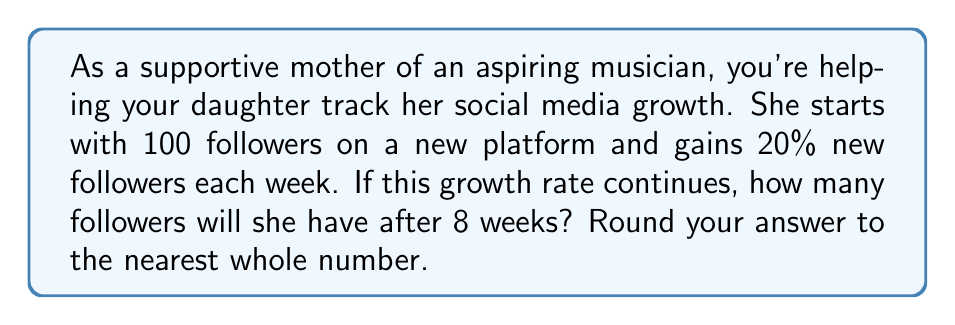Solve this math problem. Let's approach this step-by-step:

1) The initial number of followers is 100.
2) The growth rate is 20% = 0.20 per week.
3) We need to calculate this for 8 weeks.

This scenario follows an exponential growth model. The formula for exponential growth is:

$$ A = P(1 + r)^t $$

Where:
$A$ = Final amount
$P$ = Initial principal balance
$r$ = Growth rate (as a decimal)
$t$ = Number of time periods

Plugging in our values:

$$ A = 100(1 + 0.20)^8 $$

Now let's calculate:

$$ A = 100(1.20)^8 $$
$$ A = 100(4.2998) $$
$$ A = 429.98 $$

Rounding to the nearest whole number:

$$ A ≈ 430 $$
Answer: 430 followers 